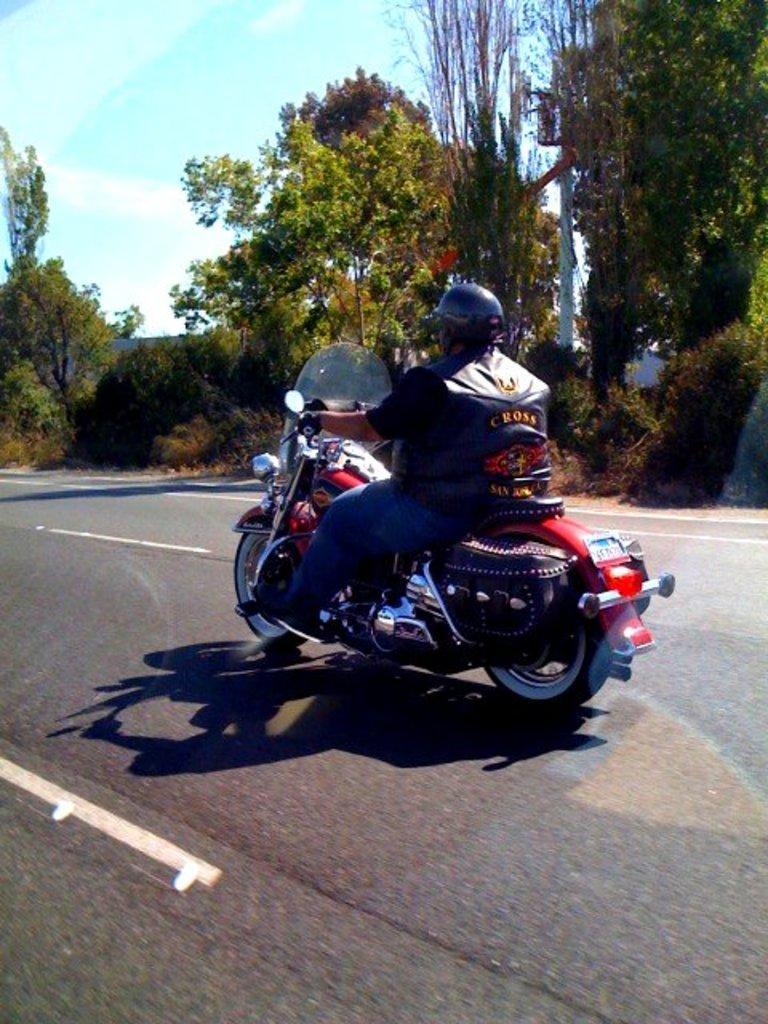Describe this image in one or two sentences. In this image can see a person riding on the motorcycle. and he's wearing a helmet and on the right corner i can see a trees and there is a sky and sky in blue color. 